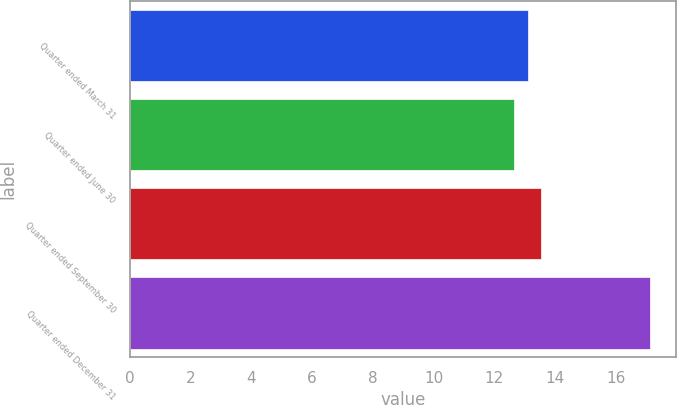Convert chart to OTSL. <chart><loc_0><loc_0><loc_500><loc_500><bar_chart><fcel>Quarter ended March 31<fcel>Quarter ended June 30<fcel>Quarter ended September 30<fcel>Quarter ended December 31<nl><fcel>13.1<fcel>12.65<fcel>13.55<fcel>17.12<nl></chart> 